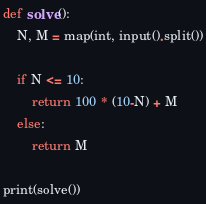<code> <loc_0><loc_0><loc_500><loc_500><_Python_>def solve():
    N, M = map(int, input().split())
    
    if N <= 10:
        return 100 * (10-N) + M
    else:
        return M

print(solve())</code> 